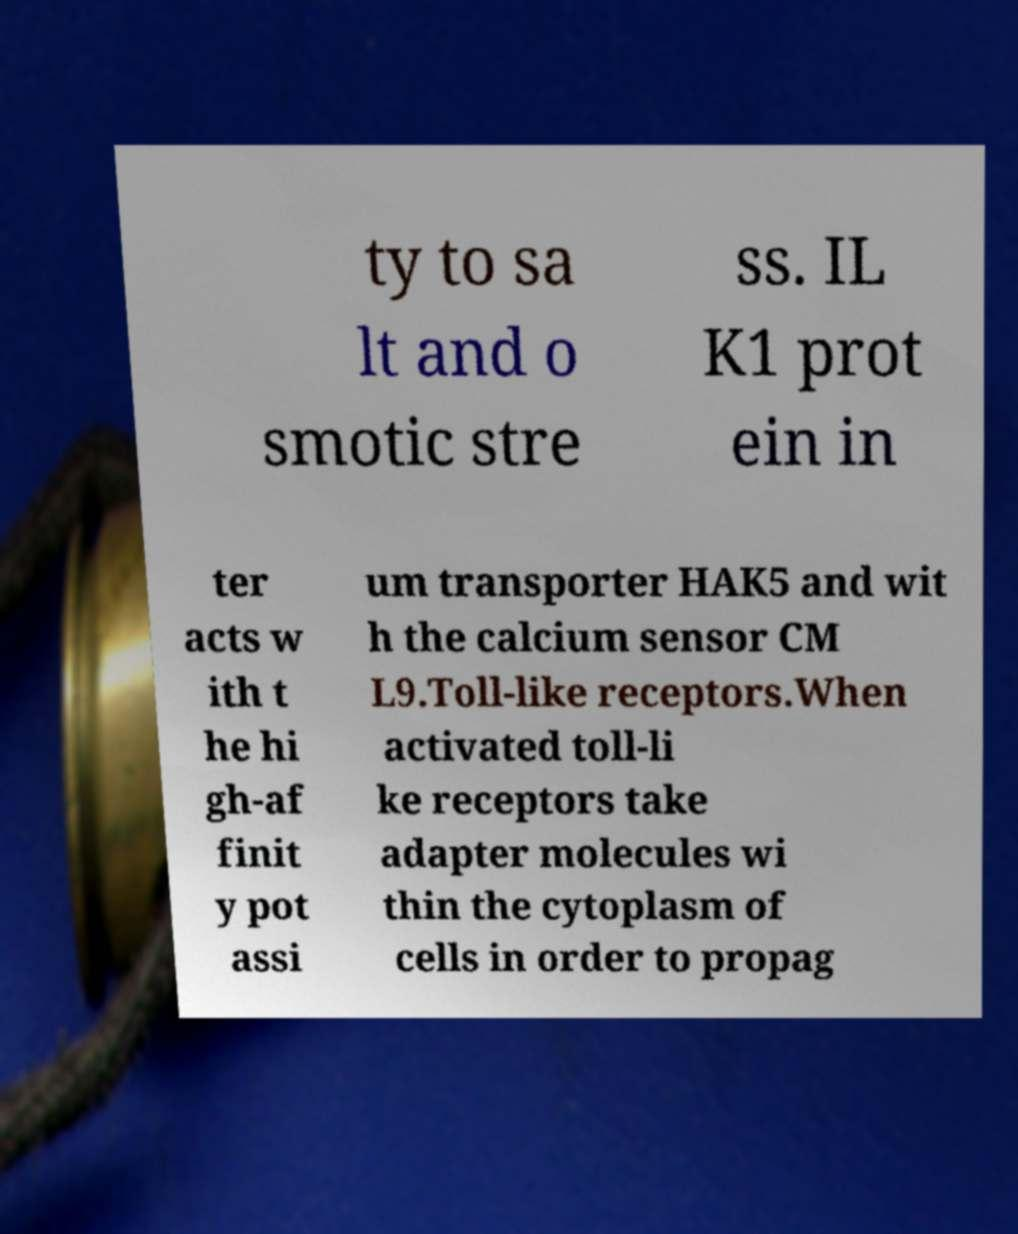For documentation purposes, I need the text within this image transcribed. Could you provide that? ty to sa lt and o smotic stre ss. IL K1 prot ein in ter acts w ith t he hi gh-af finit y pot assi um transporter HAK5 and wit h the calcium sensor CM L9.Toll-like receptors.When activated toll-li ke receptors take adapter molecules wi thin the cytoplasm of cells in order to propag 